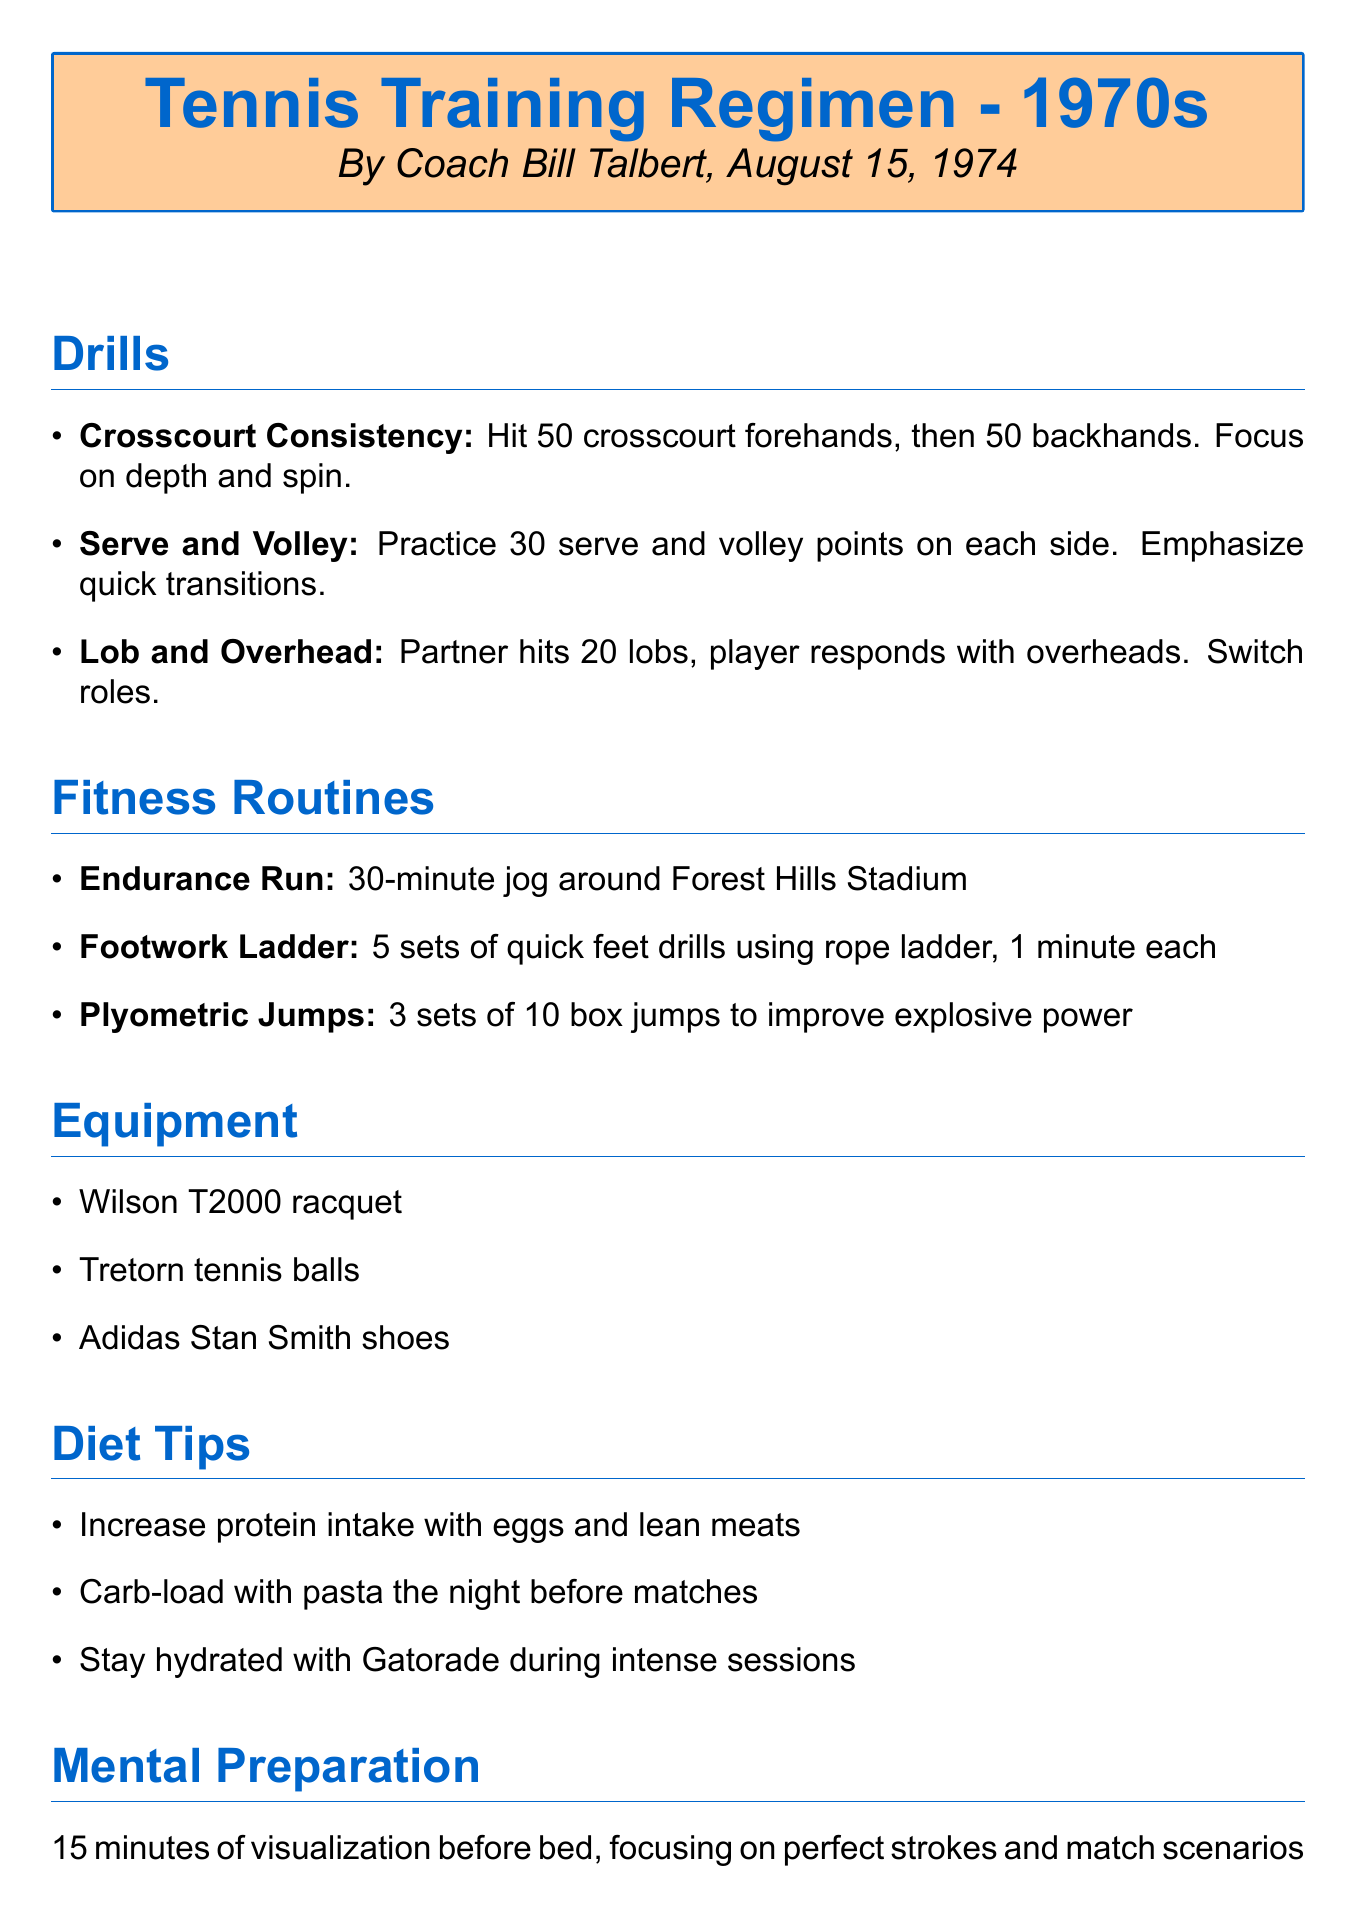What is the title of the document? The title is presented at the beginning of the document and states the main subject of the notes.
Answer: Tennis Training Regimen - 1970s Who is the author of the training regimen? The author is mentioned in the introductory section of the document, which attributes the work to a specific individual.
Answer: Coach Bill Talbert What is one drill mentioned in the document? The drills section lists specific training exercises designed to improve tennis skills.
Answer: Crosscourt Consistency How many sets of quick feet drills are included in the fitness routines? The fitness routines section specifies the number of sets for this particular drill aimed at enhancing agility.
Answer: 5 sets What is recommended for hydration during intense training sessions? The diet tips section advises on maintaining hydration when engaging in strenuous activities.
Answer: Gatorade What type of shoes are mentioned as part of the equipment? The equipment section lists specific gear recommended for players, including footwear suitable for tennis.
Answer: Adidas Stan Smith shoes How long should visualization be practiced before bed? The mental preparation section indicates the duration of this mental exercise intended to enhance focus and performance.
Answer: 15 minutes What should a player carb-load with before matches? The diet tips suggest a specific type of food to consume the night before competition to boost energy levels.
Answer: Pasta What is the duration of the endurance run? The fitness routines provide a time frame for this cardiovascular exercise aimed at building stamina.
Answer: 30-minute 